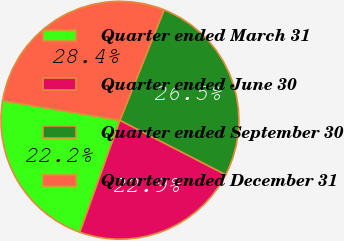<chart> <loc_0><loc_0><loc_500><loc_500><pie_chart><fcel>Quarter ended March 31<fcel>Quarter ended June 30<fcel>Quarter ended September 30<fcel>Quarter ended December 31<nl><fcel>22.16%<fcel>22.91%<fcel>26.51%<fcel>28.41%<nl></chart> 